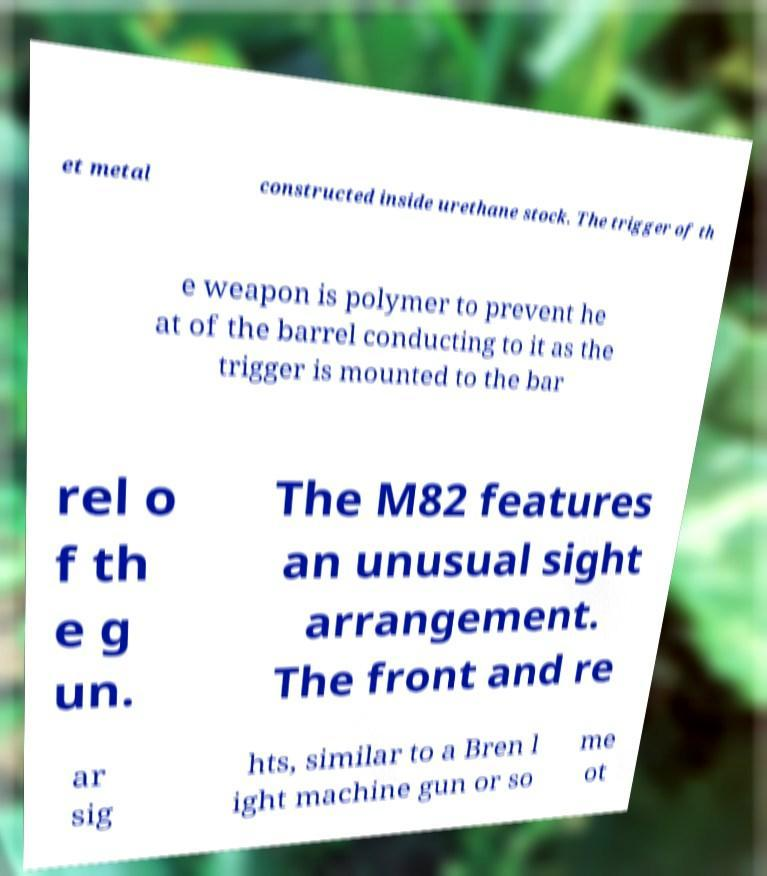For documentation purposes, I need the text within this image transcribed. Could you provide that? et metal constructed inside urethane stock. The trigger of th e weapon is polymer to prevent he at of the barrel conducting to it as the trigger is mounted to the bar rel o f th e g un. The M82 features an unusual sight arrangement. The front and re ar sig hts, similar to a Bren l ight machine gun or so me ot 